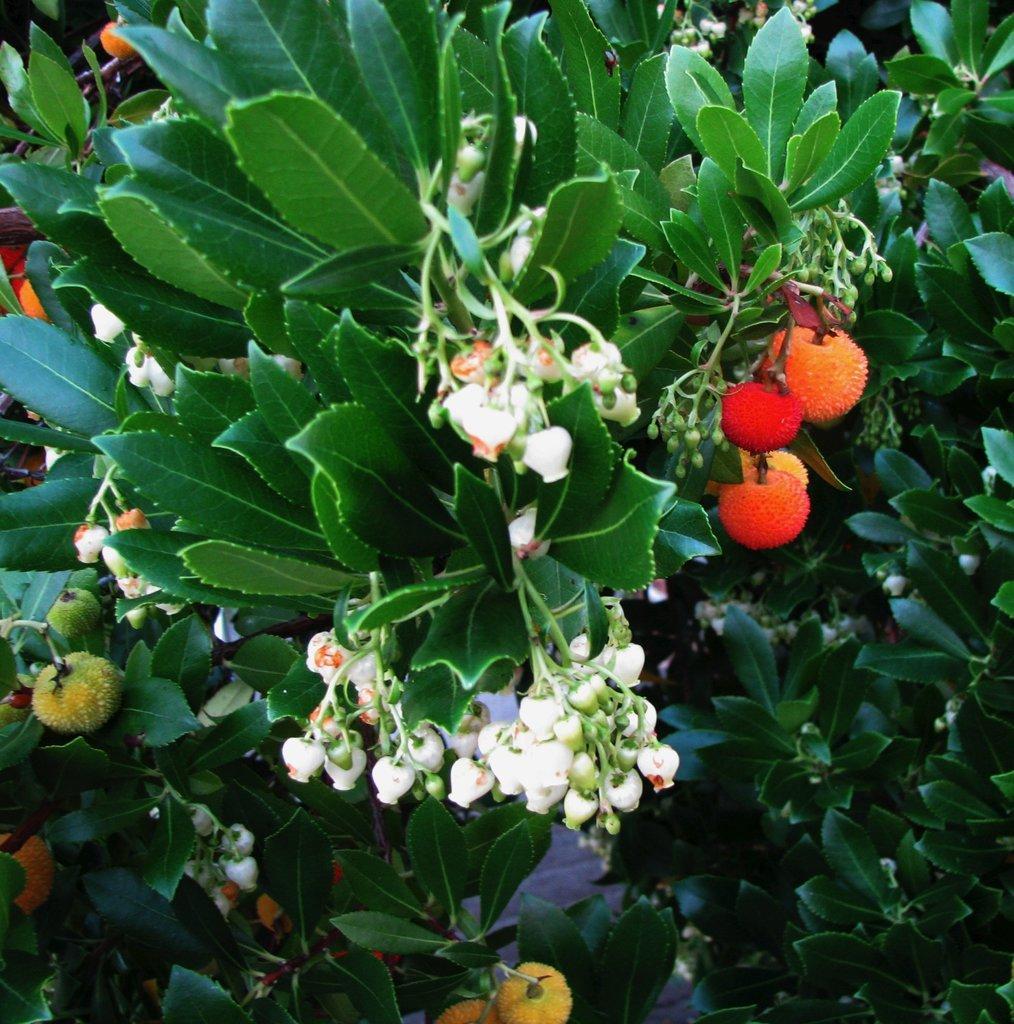Can you describe this image briefly? In this image there are some plants, and some flowers and fruits. 